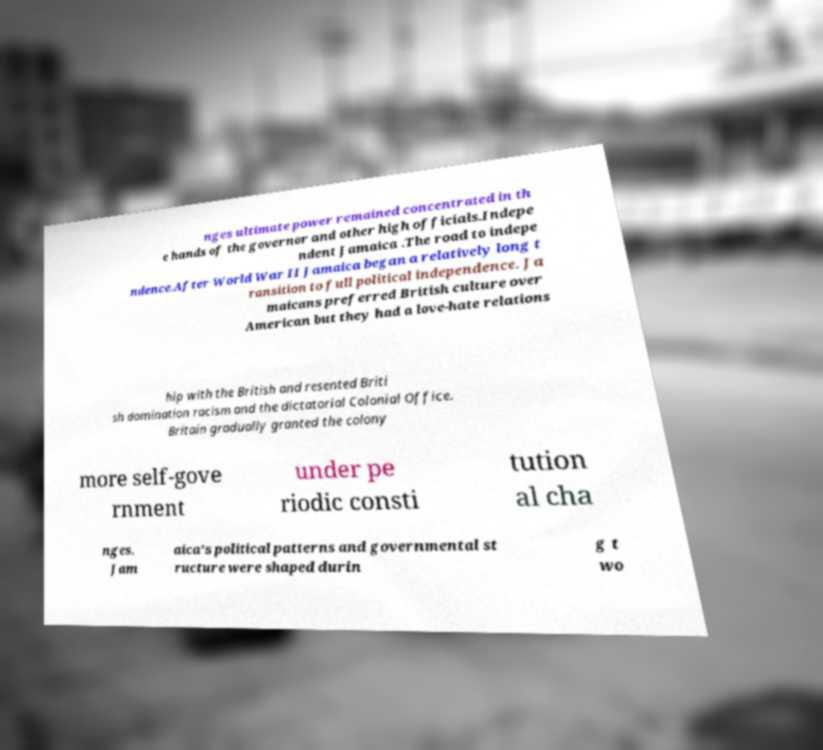Could you extract and type out the text from this image? nges ultimate power remained concentrated in th e hands of the governor and other high officials.Indepe ndent Jamaica .The road to indepe ndence.After World War II Jamaica began a relatively long t ransition to full political independence. Ja maicans preferred British culture over American but they had a love-hate relations hip with the British and resented Briti sh domination racism and the dictatorial Colonial Office. Britain gradually granted the colony more self-gove rnment under pe riodic consti tution al cha nges. Jam aica's political patterns and governmental st ructure were shaped durin g t wo 